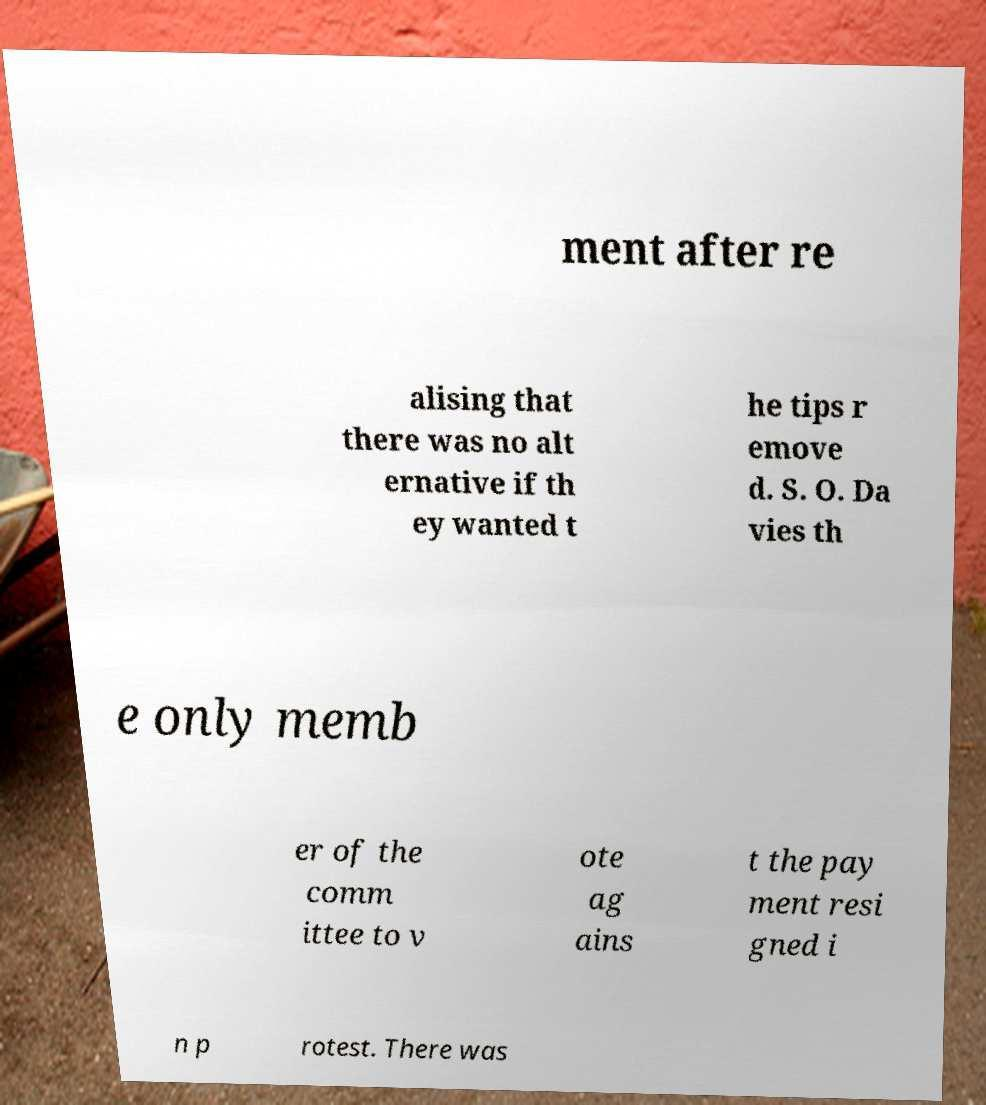Could you extract and type out the text from this image? ment after re alising that there was no alt ernative if th ey wanted t he tips r emove d. S. O. Da vies th e only memb er of the comm ittee to v ote ag ains t the pay ment resi gned i n p rotest. There was 